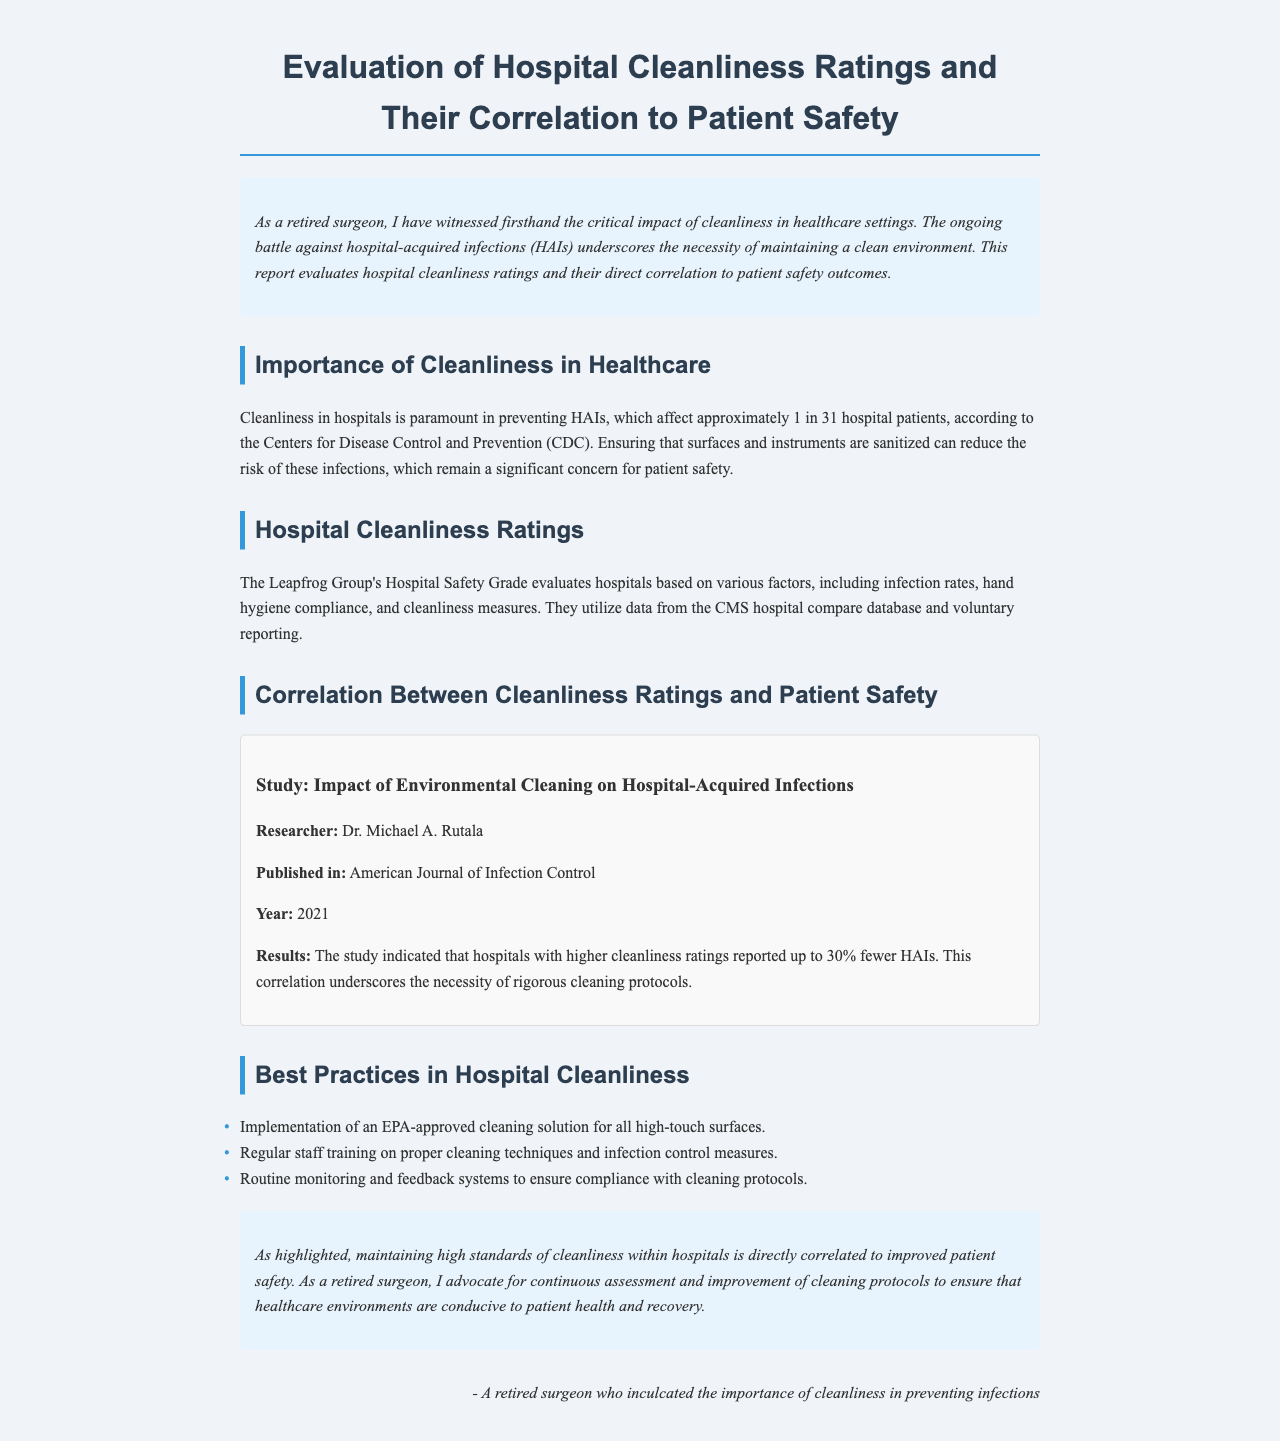What is the title of the report? The title is stated at the top of the document as the main heading.
Answer: Evaluation of Hospital Cleanliness Ratings and Their Correlation to Patient Safety Who is the researcher mentioned in the study? The researcher’s name is provided in the study section of the report.
Answer: Dr. Michael A. Rutala What is the published year of the study? The publication year is listed under the researcher’s information in the study.
Answer: 2021 What percentage fewer hospital-acquired infections are reported by hospitals with higher cleanliness ratings? This percentage is highlighted in the results section of the study.
Answer: 30% What organization evaluates hospitals based on cleanliness measures? The document specifies the organization that assesses hospitals related to safety grades.
Answer: The Leapfrog Group What is one of the best practices in hospital cleanliness mentioned? The document lists specific practices that contribute to better cleanliness.
Answer: Implementation of an EPA-approved cleaning solution for all high-touch surfaces How does the document describe the relationship between cleanliness and patient safety? This relationship is implied through the findings and conclusion sections of the report.
Answer: Directly correlated What type of infections does the report highlight as a concern for patient safety? The document specifies the type of infections that are discussed in relation to cleanliness.
Answer: Hospital-acquired infections (HAIs) 